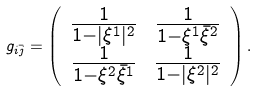Convert formula to latex. <formula><loc_0><loc_0><loc_500><loc_500>g _ { i \bar { j } } = \left ( \begin{array} { c c } \frac { 1 } { 1 - | \xi ^ { 1 } | ^ { 2 } } & \frac { 1 } { 1 - \xi ^ { 1 } \bar { \xi } ^ { 2 } } \\ \frac { 1 } { 1 - \xi ^ { 2 } \bar { \xi } ^ { 1 } } & \frac { 1 } { 1 - | \xi ^ { 2 } | ^ { 2 } } \end{array} \right ) .</formula> 